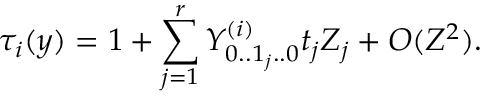Convert formula to latex. <formula><loc_0><loc_0><loc_500><loc_500>\tau _ { i } ( y ) = 1 + \sum _ { j = 1 } ^ { r } Y _ { 0 . . 1 _ { j } . . 0 } ^ { ( i ) } t _ { j } Z _ { j } + O ( Z ^ { 2 } ) .</formula> 